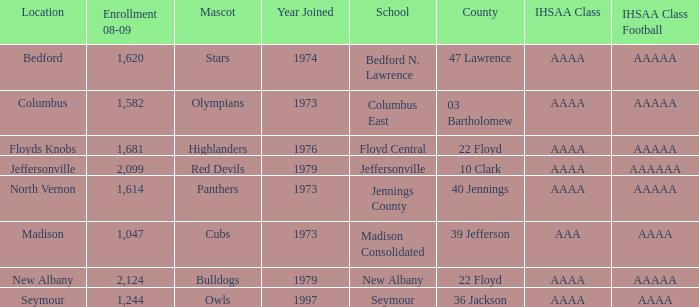What's the IHSAA Class Football if the panthers are the mascot? AAAAA. 